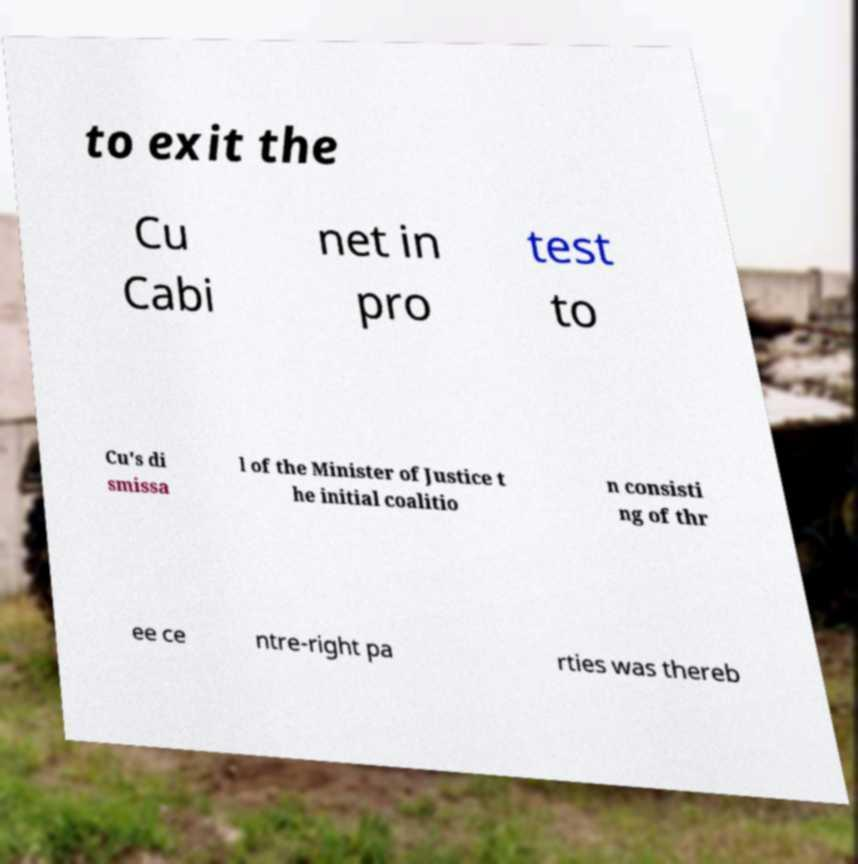There's text embedded in this image that I need extracted. Can you transcribe it verbatim? to exit the Cu Cabi net in pro test to Cu's di smissa l of the Minister of Justice t he initial coalitio n consisti ng of thr ee ce ntre-right pa rties was thereb 